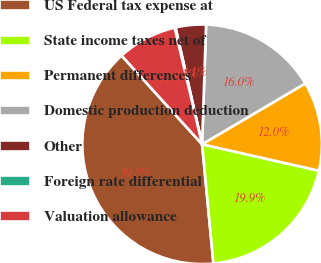Convert chart. <chart><loc_0><loc_0><loc_500><loc_500><pie_chart><fcel>US Federal tax expense at<fcel>State income taxes net of<fcel>Permanent differences<fcel>Domestic production deduction<fcel>Other<fcel>Foreign rate differential<fcel>Valuation allowance<nl><fcel>39.78%<fcel>19.95%<fcel>12.02%<fcel>15.99%<fcel>4.09%<fcel>0.12%<fcel>8.05%<nl></chart> 